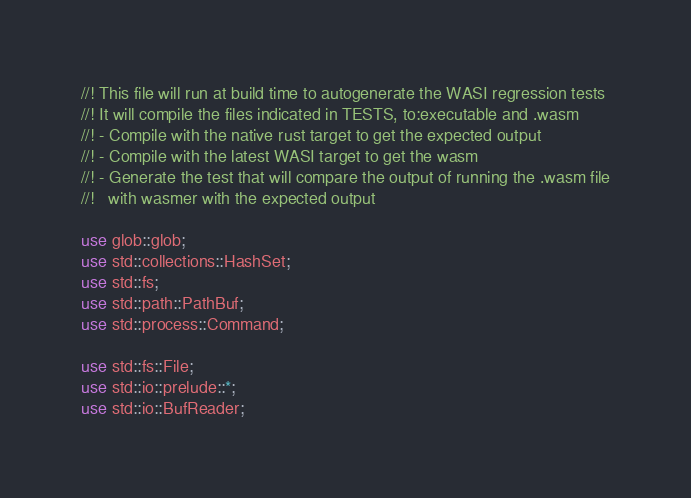Convert code to text. <code><loc_0><loc_0><loc_500><loc_500><_Rust_>//! This file will run at build time to autogenerate the WASI regression tests
//! It will compile the files indicated in TESTS, to:executable and .wasm
//! - Compile with the native rust target to get the expected output
//! - Compile with the latest WASI target to get the wasm
//! - Generate the test that will compare the output of running the .wasm file
//!   with wasmer with the expected output

use glob::glob;
use std::collections::HashSet;
use std::fs;
use std::path::PathBuf;
use std::process::Command;

use std::fs::File;
use std::io::prelude::*;
use std::io::BufReader;
</code> 